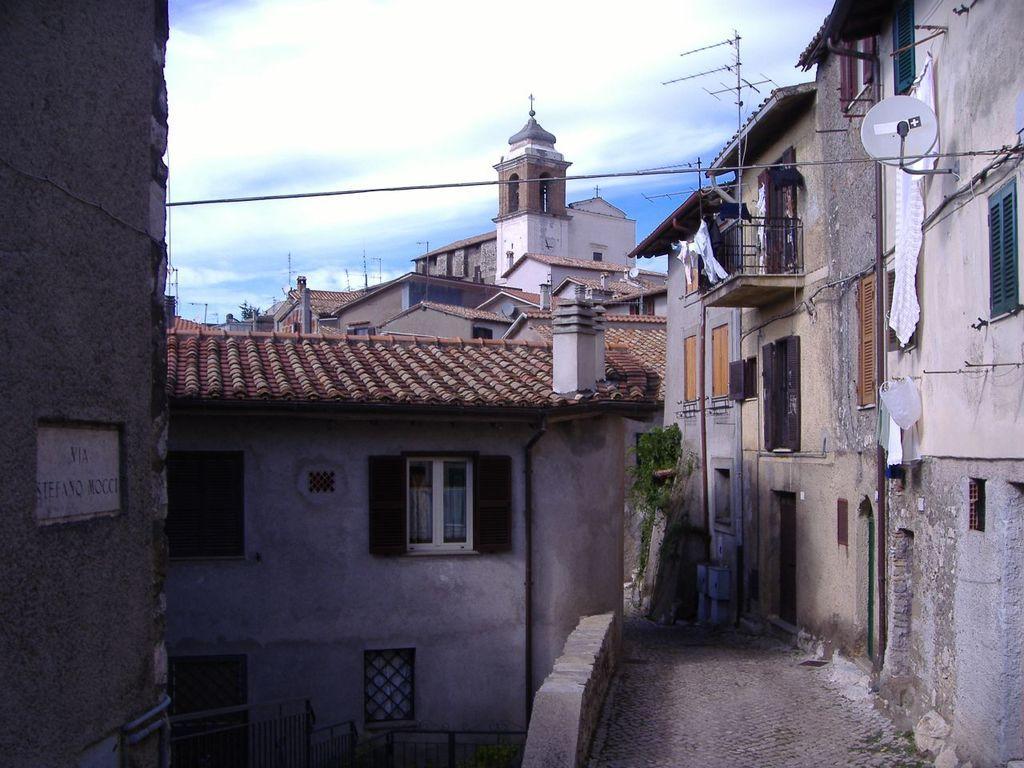Please provide a concise description of this image. In this picture, we can see a few building with windows, doors, poles, fencing, and a few objects attached to it, we can see name plate, and the sky with clouds. 